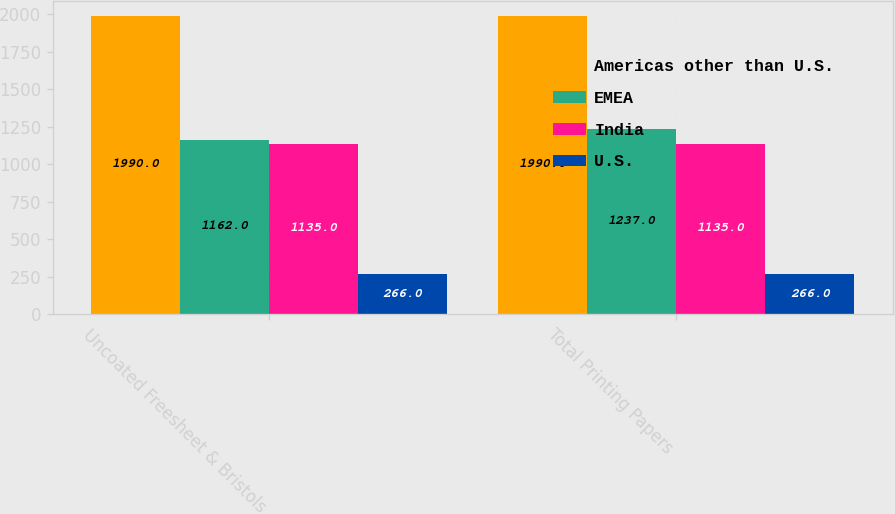<chart> <loc_0><loc_0><loc_500><loc_500><stacked_bar_chart><ecel><fcel>Uncoated Freesheet & Bristols<fcel>Total Printing Papers<nl><fcel>Americas other than U.S.<fcel>1990<fcel>1990<nl><fcel>EMEA<fcel>1162<fcel>1237<nl><fcel>India<fcel>1135<fcel>1135<nl><fcel>U.S.<fcel>266<fcel>266<nl></chart> 